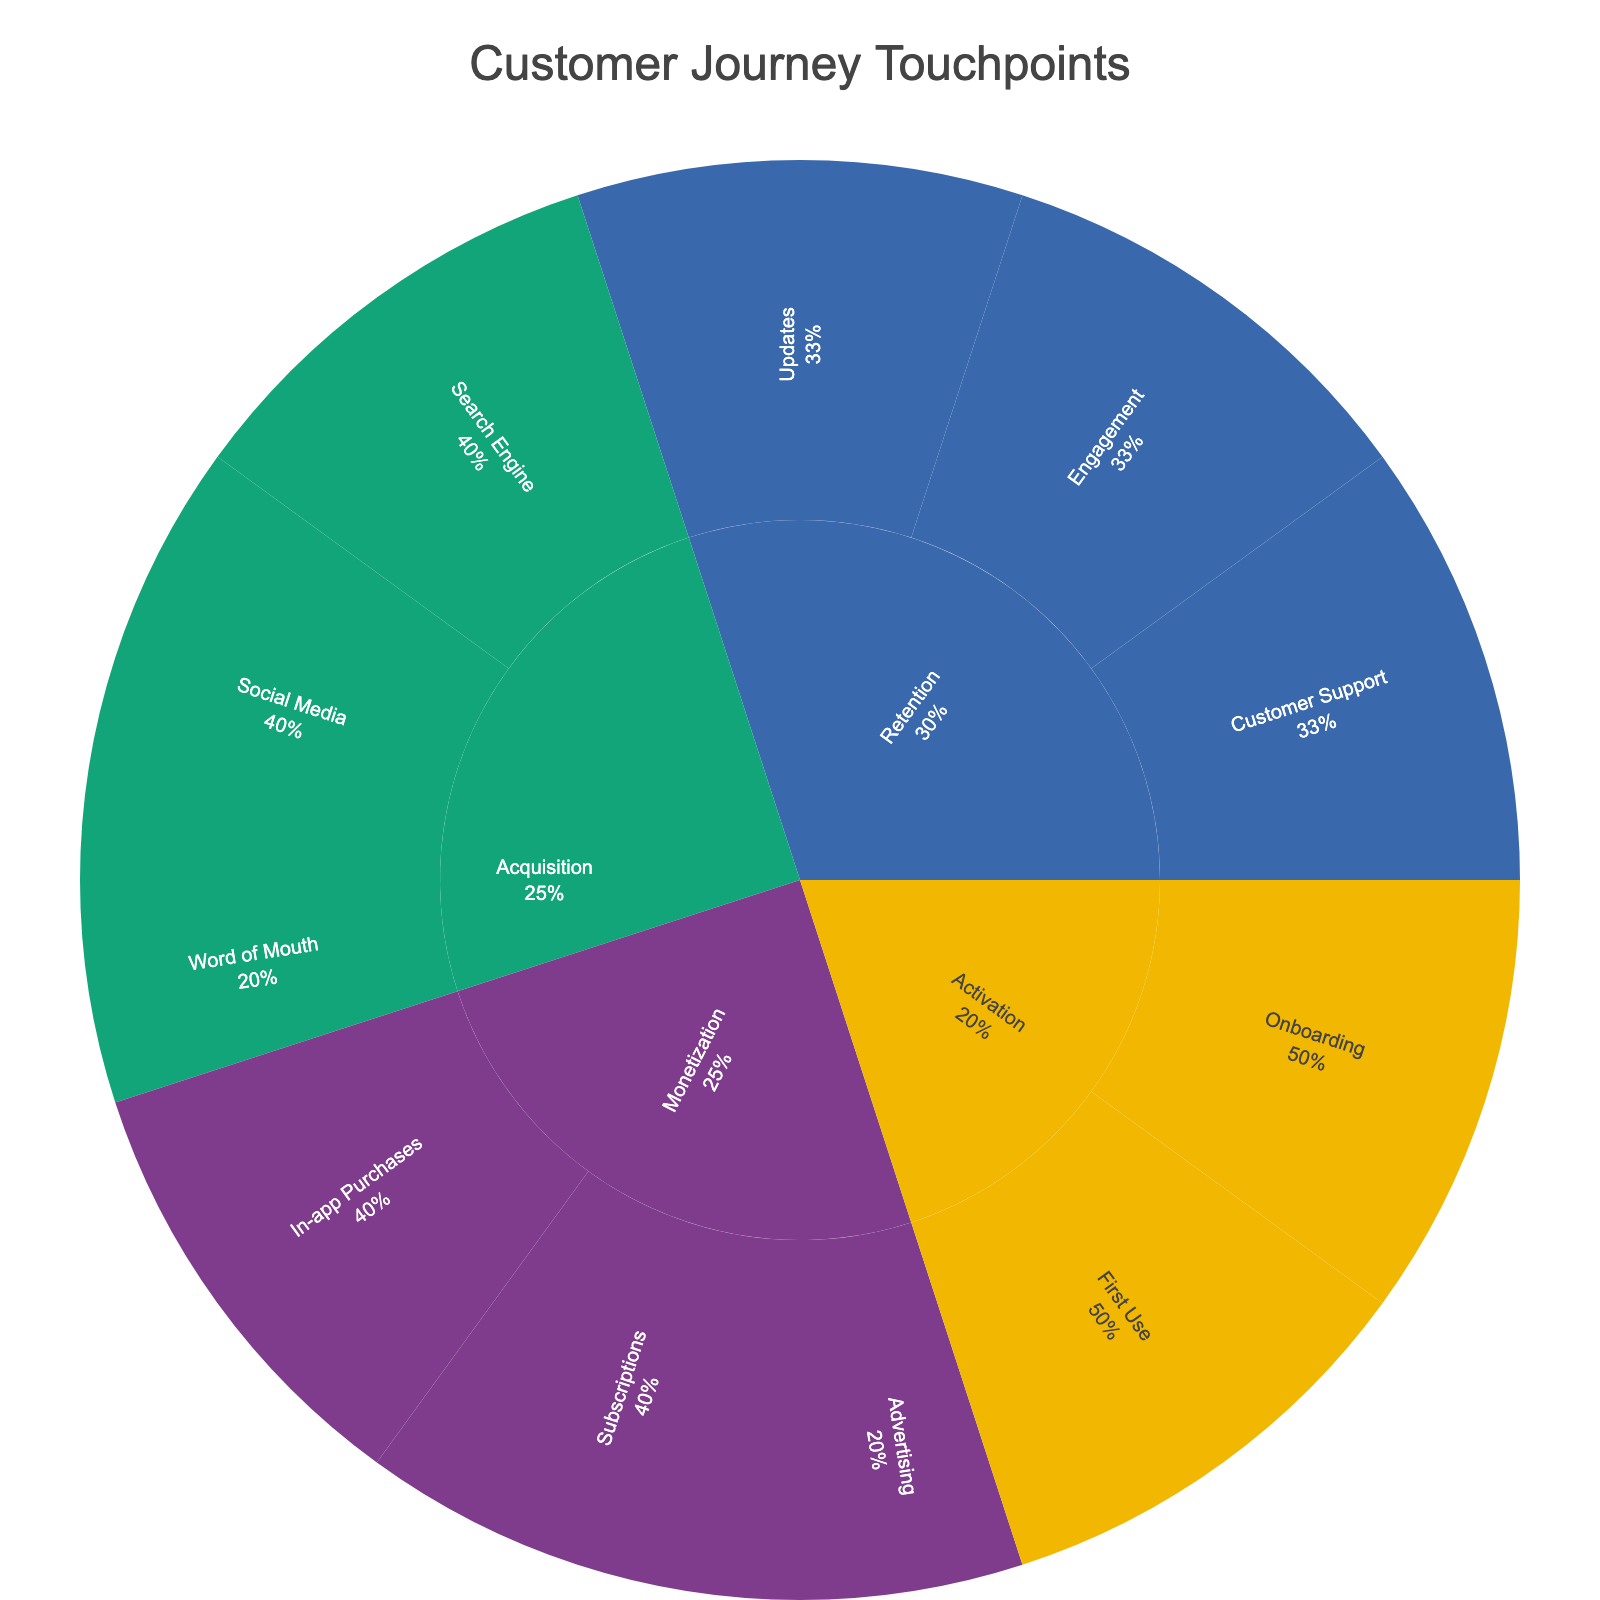What are the four main stages in the customer journey shown in the sunburst plot? The sunburst plot is divided into four main stages, each represented by a different primary color.
Answer: Acquisition, Activation, Retention, Monetization Which stage has the touchpoint 'Word of Mouth'? By looking at the sunburst plot, you can trace where 'Word of Mouth' appears in relation to the primary categories.
Answer: Acquisition What percentage of the Activation stage is attributed to 'First Use' touchpoints? Looking at the Activation stage, you can see that 'First Use' is a subcategory. The percentage information should be labeled alongside 'First Use'.
Answer: (value from the plot, typically around 50%) How many sub_touchpoints are there in the Monetization stage? Each touchpoint in the Monetization stage branches into smaller sub_touchpoints. Counting these will provide the answer.
Answer: 5 Compare 'Onboarding' and 'First Use' touchpoints in terms of their contributions to the Activation stage. Which one has a higher percentage? By examining the Activation stage, you can see the percentages labeled for 'Onboarding' and 'First Use'. The one with the higher percentage can be identified this way.
Answer: (value from the plot, typically around equal) Within the Retention stage, does 'Customer Support' or 'Updates' have more sub_touchpoints? The Retention stage branches into different touchpoints, each of which further branches into sub_touchpoints. Counting each branch's sub_touchpoints will provide the answer.
Answer: Updates Which sub_touchpoint under 'Search Engine' in the Acquisition stage appears on the sunburst plot? Under the Acquisition stage, locate the 'Search Engine' touchpoint and then identify its subcategories.
Answer: Google Play Store and App Store Optimization What is the proportion of 'Social Media' touchpoints in the Acquisition stage? The Acquisition stage will show percentages for each category, including 'Social Media'. The sum of the percentages for 'Facebook Ads' and 'Instagram Stories' gives the total proportion.
Answer: (value from the plot, typically around half) Is there a greater number of touchpoints under 'In-app Purchases' or 'Subscriptions' in the Monetization stage? By observing the branches under the Monetization stage for 'In-app Purchases' and 'Subscriptions,' you can count the number of sub_touchpoints for each.
Answer: In-app Purchases 